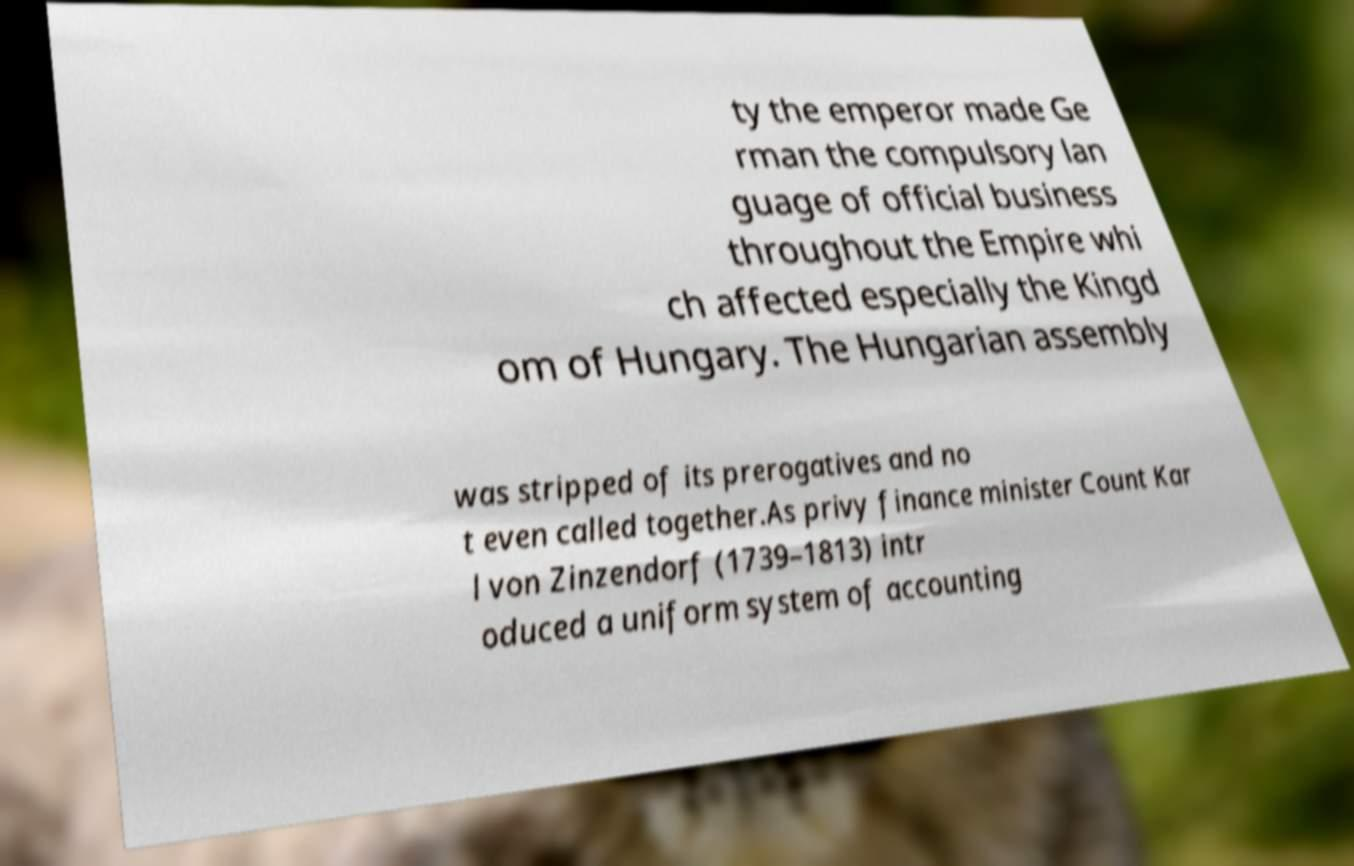Please identify and transcribe the text found in this image. ty the emperor made Ge rman the compulsory lan guage of official business throughout the Empire whi ch affected especially the Kingd om of Hungary. The Hungarian assembly was stripped of its prerogatives and no t even called together.As privy finance minister Count Kar l von Zinzendorf (1739–1813) intr oduced a uniform system of accounting 